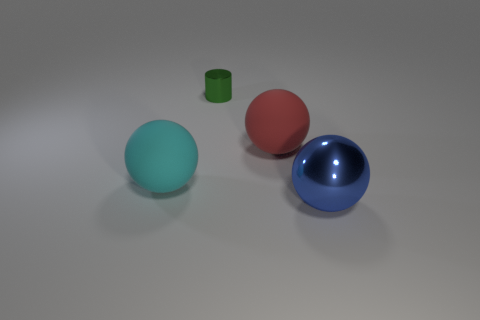There is a rubber object to the right of the tiny green metal object; is its size the same as the matte sphere that is to the left of the small green cylinder?
Ensure brevity in your answer.  Yes. What number of small objects are cylinders or blue shiny things?
Your answer should be compact. 1. What number of large rubber spheres are both on the right side of the green thing and on the left side of the tiny green metallic object?
Offer a very short reply. 0. Are the large cyan object and the big blue ball that is in front of the cylinder made of the same material?
Provide a short and direct response. No. How many green objects are rubber spheres or tiny cylinders?
Keep it short and to the point. 1. Is there another metallic object of the same size as the green metal object?
Give a very brief answer. No. What material is the big thing to the left of the rubber thing that is on the right side of the matte ball that is left of the green object?
Ensure brevity in your answer.  Rubber. Is the number of big objects left of the green metallic object the same as the number of large cyan objects?
Keep it short and to the point. Yes. Is the large sphere that is behind the big cyan matte ball made of the same material as the big ball that is in front of the cyan matte object?
Ensure brevity in your answer.  No. How many objects are either cyan objects or large balls right of the large cyan ball?
Provide a succinct answer. 3. 